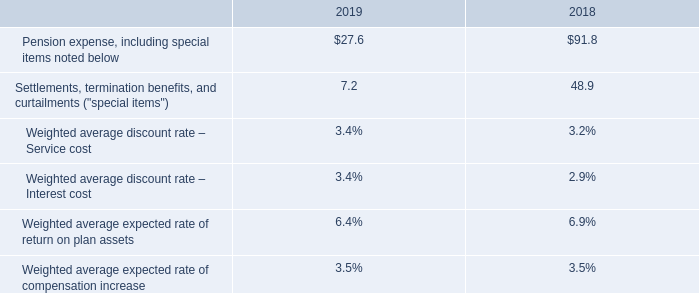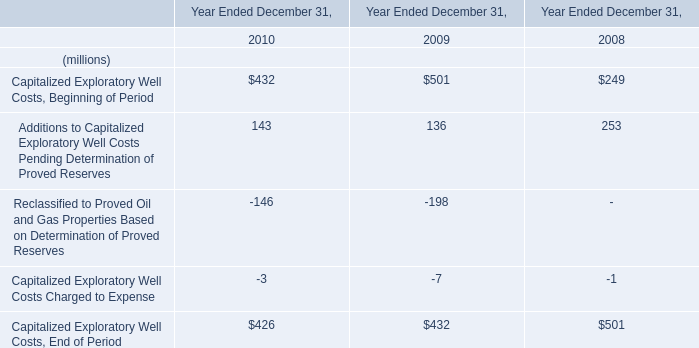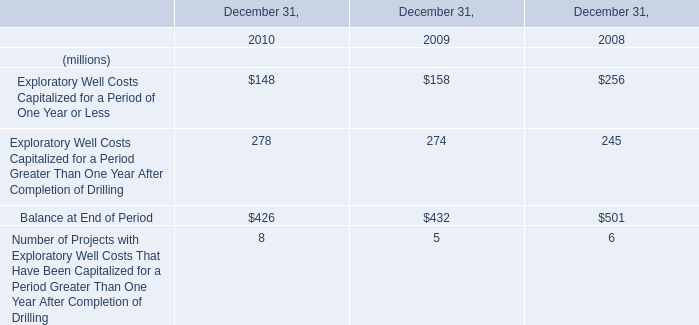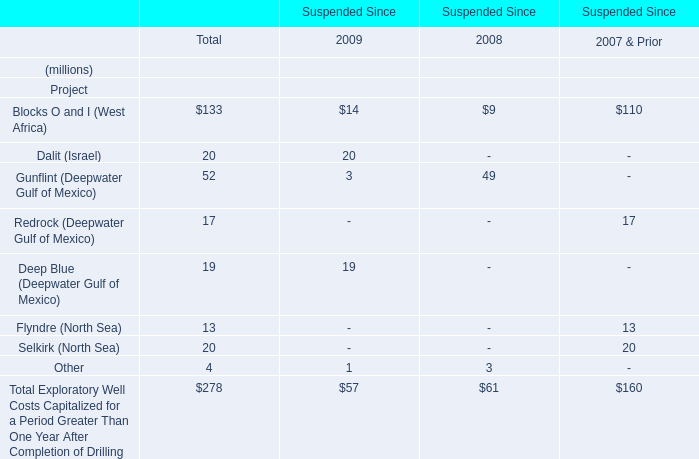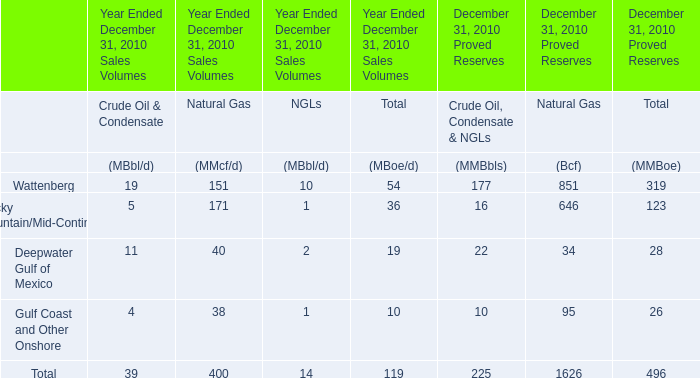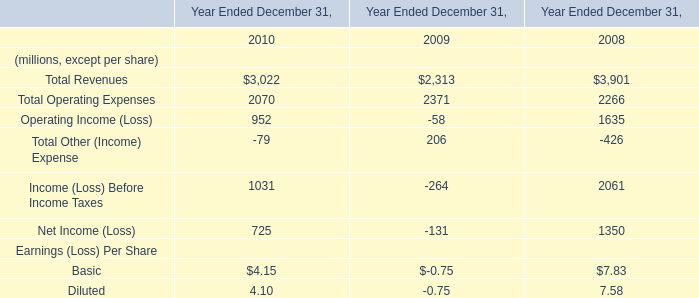What is the sum of the Capitalized Exploratory Well Costs, End of Period in the years where Capitalized Exploratory Well Costs, Beginning of Period greater than 500? (in million) 
Computations: (((501 + 136) - 198) - 7)
Answer: 432.0. 